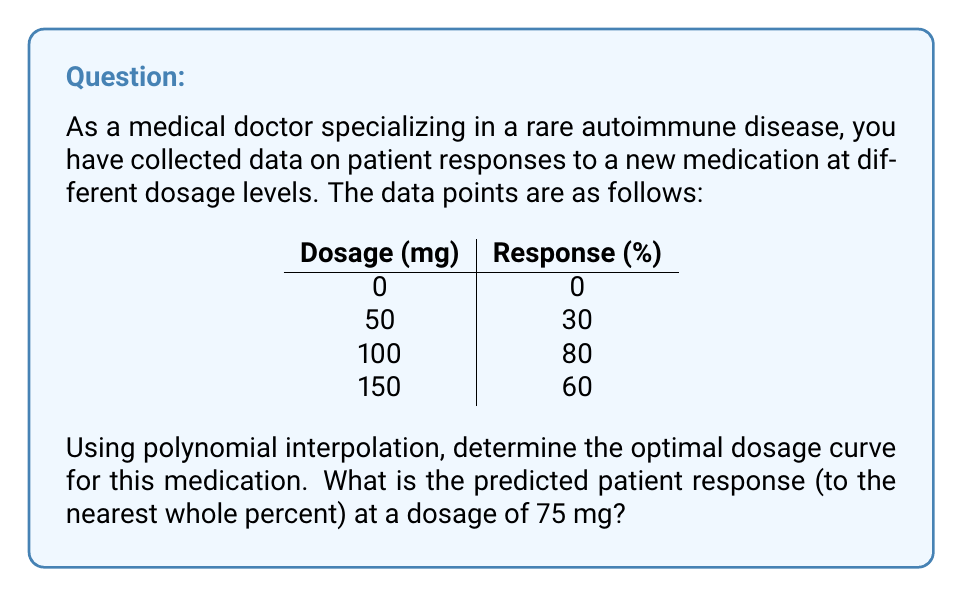Provide a solution to this math problem. To solve this problem, we'll use Lagrange polynomial interpolation to find the optimal dosage curve, then use that polynomial to predict the response at 75 mg.

Step 1: Set up the Lagrange interpolation formula
$$P(x) = \sum_{i=0}^{n} y_i \prod_{j \neq i} \frac{x - x_j}{x_i - x_j}$$

where $(x_i, y_i)$ are the given data points.

Step 2: Calculate the Lagrange basis polynomials
$$L_0(x) = \frac{(x-50)(x-100)(x-150)}{(0-50)(0-100)(0-150)}$$
$$L_1(x) = \frac{(x-0)(x-100)(x-150)}{(50-0)(50-100)(50-150)}$$
$$L_2(x) = \frac{(x-0)(x-50)(x-150)}{(100-0)(100-50)(100-150)}$$
$$L_3(x) = \frac{(x-0)(x-50)(x-100)}{(150-0)(150-50)(150-100)}$$

Step 3: Construct the interpolation polynomial
$$P(x) = 0 \cdot L_0(x) + 30 \cdot L_1(x) + 80 \cdot L_2(x) + 60 \cdot L_3(x)$$

Step 4: Simplify the polynomial (using a computer algebra system)
$$P(x) = -\frac{2}{15000}x^3 + \frac{1}{100}x^2 + \frac{14}{25}x$$

Step 5: Evaluate P(75) to find the predicted response at 75 mg
$$P(75) = -\frac{2}{15000}(75^3) + \frac{1}{100}(75^2) + \frac{14}{25}(75) = 61.25$$

Step 6: Round to the nearest whole percent
61.25% rounds to 61%
Answer: 61% 